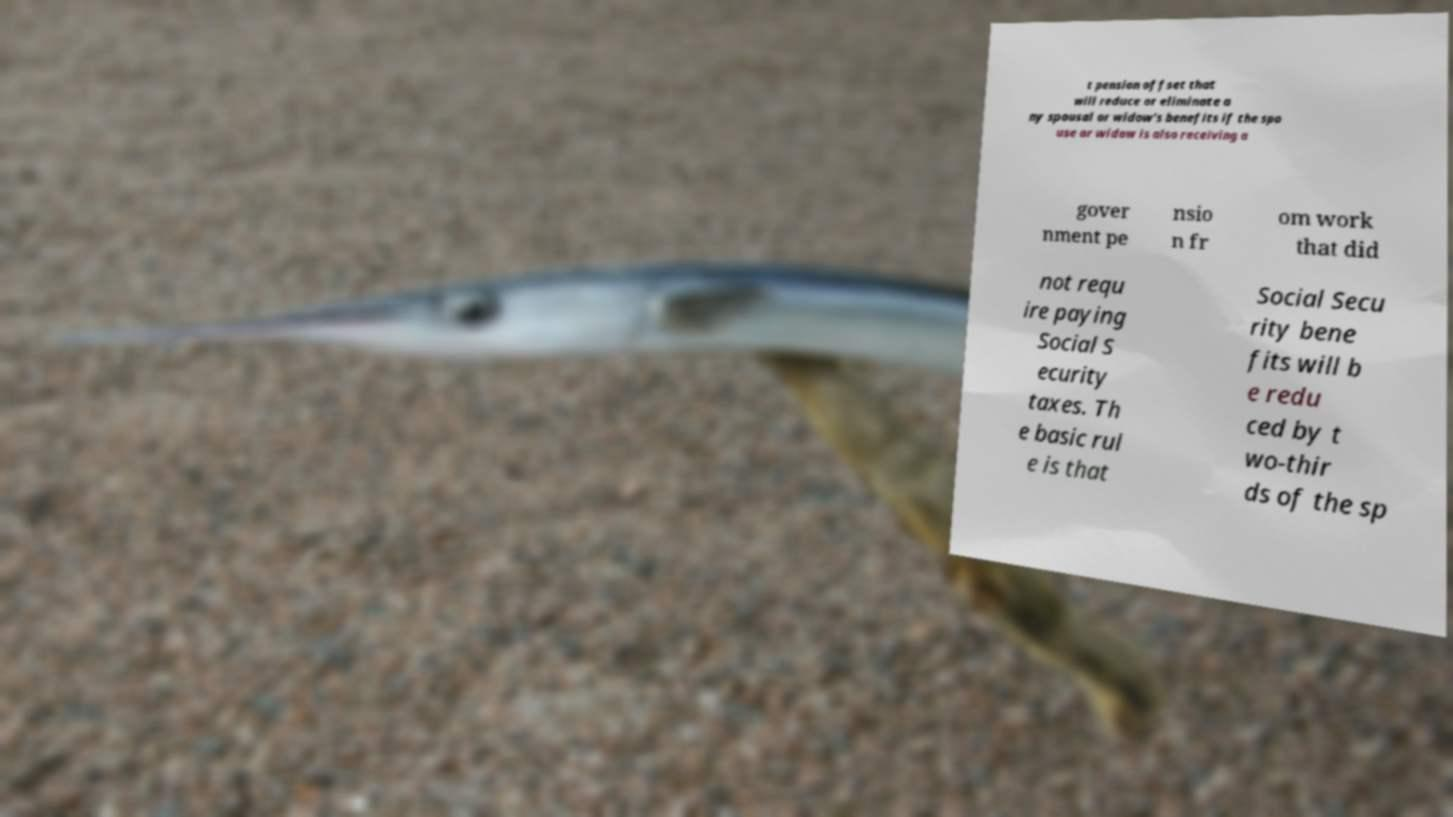For documentation purposes, I need the text within this image transcribed. Could you provide that? t pension offset that will reduce or eliminate a ny spousal or widow's benefits if the spo use or widow is also receiving a gover nment pe nsio n fr om work that did not requ ire paying Social S ecurity taxes. Th e basic rul e is that Social Secu rity bene fits will b e redu ced by t wo-thir ds of the sp 